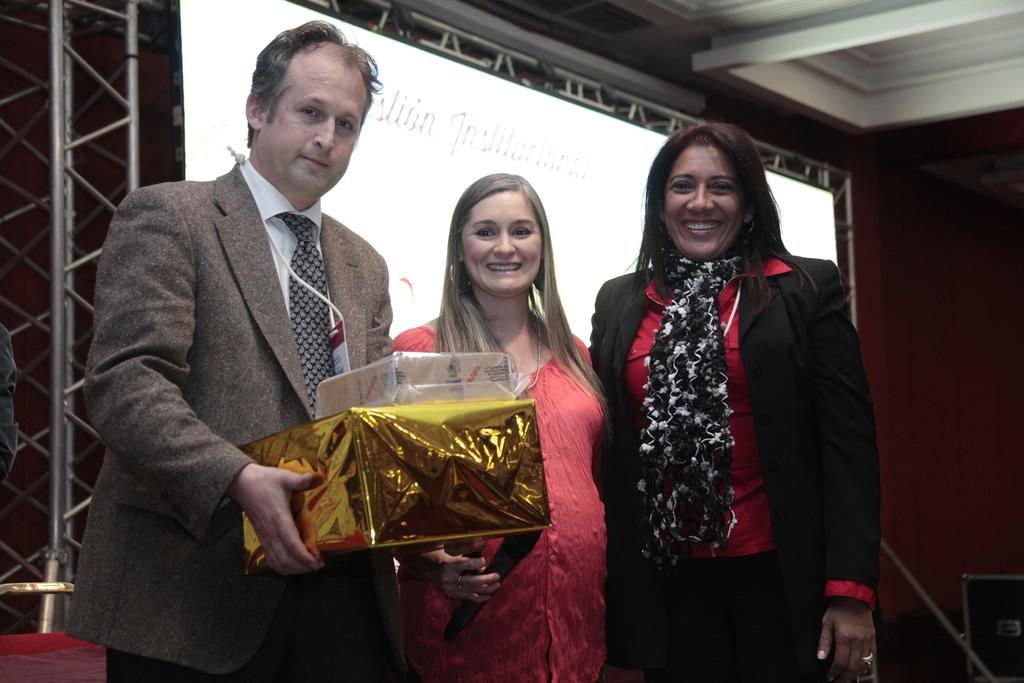What are the people in the image doing? The people in the image are standing. What is one person holding in the image? One person is holding gift boxes. What can be seen on the wall or structure in the image? There is a screen visible in the image. What material is used for the framing in the image? Metal framing is present in the image. What type of boot is being used to pull the carriage in the image? There is no boot or carriage present in the image. 